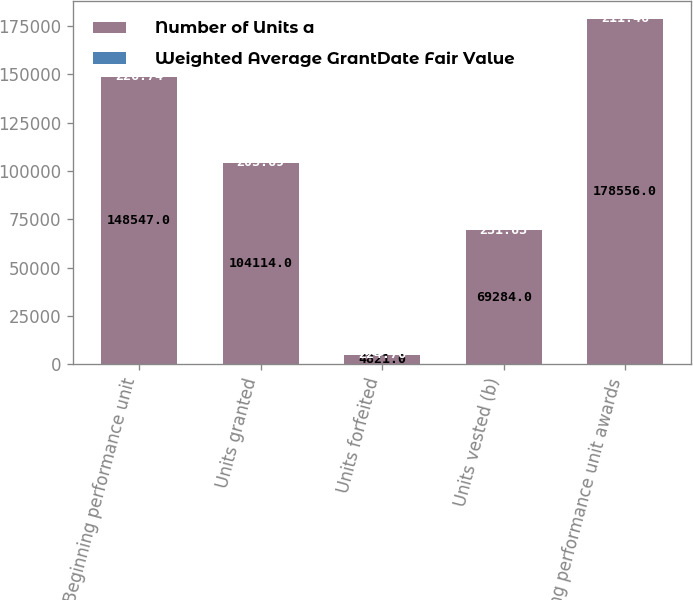<chart> <loc_0><loc_0><loc_500><loc_500><stacked_bar_chart><ecel><fcel>Beginning performance unit<fcel>Units granted<fcel>Units forfeited<fcel>Units vested (b)<fcel>Ending performance unit awards<nl><fcel>Number of Units a<fcel>148547<fcel>104114<fcel>4821<fcel>69284<fcel>178556<nl><fcel>Weighted Average GrantDate Fair Value<fcel>226.74<fcel>203.69<fcel>224.76<fcel>231.63<fcel>211.46<nl></chart> 